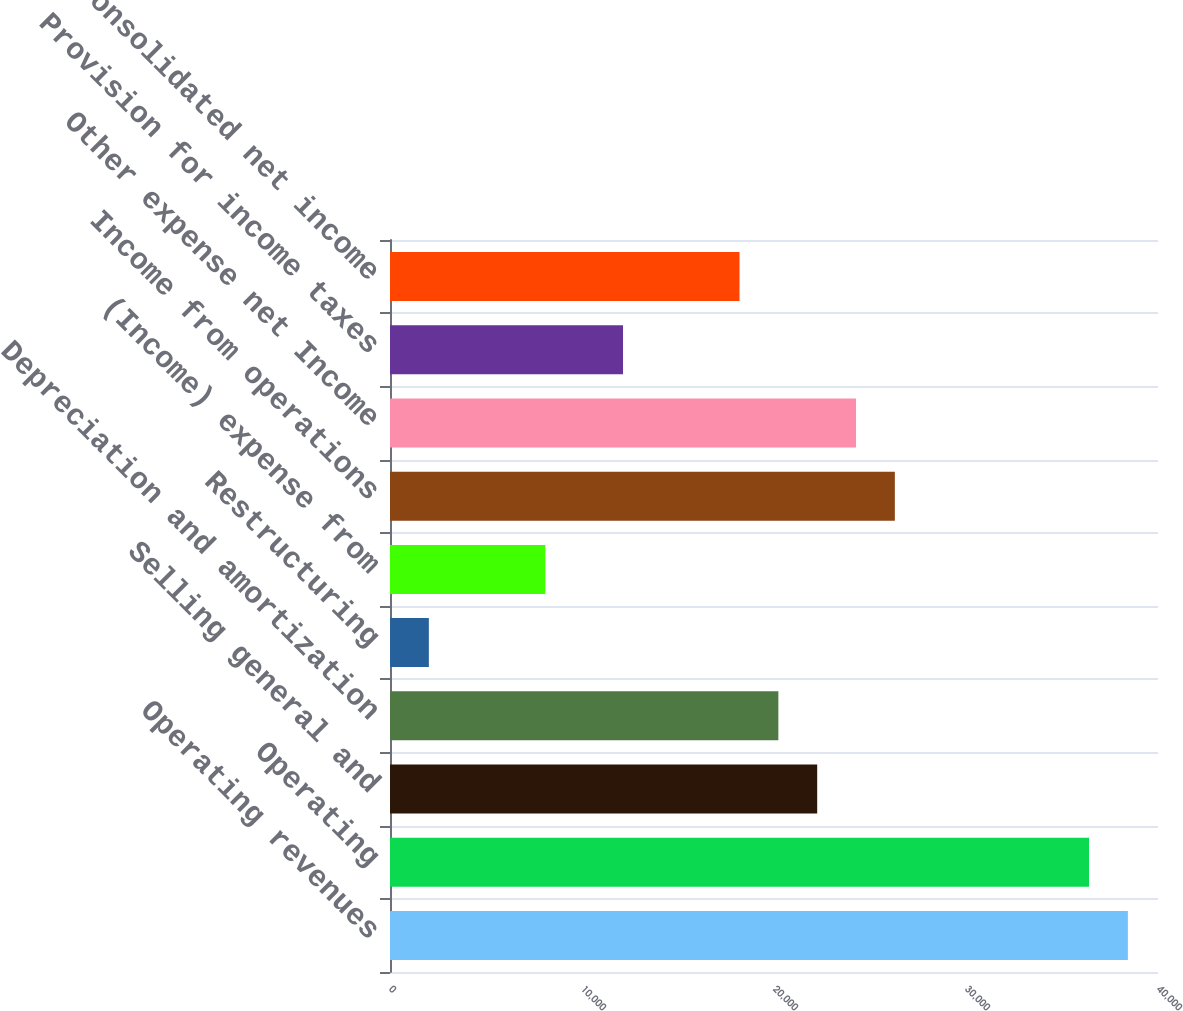<chart> <loc_0><loc_0><loc_500><loc_500><bar_chart><fcel>Operating revenues<fcel>Operating<fcel>Selling general and<fcel>Depreciation and amortization<fcel>Restructuring<fcel>(Income) expense from<fcel>Income from operations<fcel>Other expense net Income<fcel>Provision for income taxes<fcel>Consolidated net income<nl><fcel>38430.3<fcel>36407.7<fcel>22249.6<fcel>20227<fcel>2023.67<fcel>8091.44<fcel>26294.8<fcel>24272.2<fcel>12136.6<fcel>18204.4<nl></chart> 